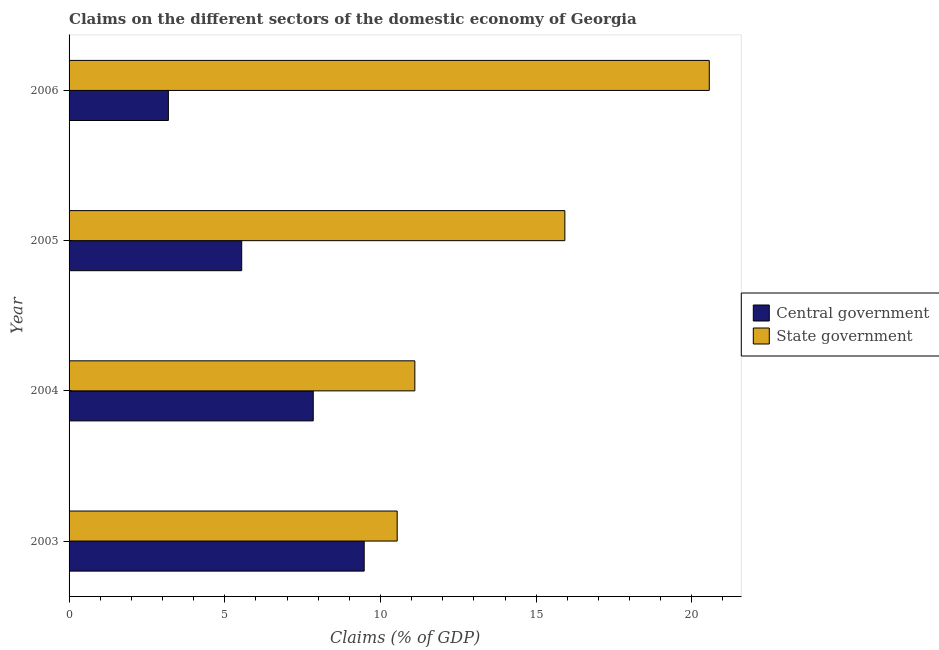Are the number of bars per tick equal to the number of legend labels?
Offer a very short reply. Yes. Are the number of bars on each tick of the Y-axis equal?
Provide a succinct answer. Yes. How many bars are there on the 1st tick from the top?
Your answer should be compact. 2. How many bars are there on the 2nd tick from the bottom?
Provide a succinct answer. 2. What is the label of the 3rd group of bars from the top?
Ensure brevity in your answer.  2004. In how many cases, is the number of bars for a given year not equal to the number of legend labels?
Offer a very short reply. 0. What is the claims on state government in 2006?
Make the answer very short. 20.56. Across all years, what is the maximum claims on central government?
Provide a succinct answer. 9.48. Across all years, what is the minimum claims on state government?
Keep it short and to the point. 10.54. In which year was the claims on central government maximum?
Provide a short and direct response. 2003. In which year was the claims on state government minimum?
Provide a succinct answer. 2003. What is the total claims on central government in the graph?
Your response must be concise. 26.05. What is the difference between the claims on state government in 2003 and that in 2004?
Provide a succinct answer. -0.57. What is the difference between the claims on central government in 2005 and the claims on state government in 2003?
Keep it short and to the point. -4.99. What is the average claims on state government per year?
Your answer should be compact. 14.53. In the year 2005, what is the difference between the claims on central government and claims on state government?
Make the answer very short. -10.38. In how many years, is the claims on state government greater than 18 %?
Provide a succinct answer. 1. What is the ratio of the claims on state government in 2003 to that in 2005?
Give a very brief answer. 0.66. What is the difference between the highest and the second highest claims on central government?
Your answer should be compact. 1.64. What is the difference between the highest and the lowest claims on state government?
Your answer should be compact. 10.02. In how many years, is the claims on state government greater than the average claims on state government taken over all years?
Ensure brevity in your answer.  2. What does the 1st bar from the top in 2005 represents?
Give a very brief answer. State government. What does the 2nd bar from the bottom in 2006 represents?
Offer a terse response. State government. How many years are there in the graph?
Make the answer very short. 4. What is the difference between two consecutive major ticks on the X-axis?
Keep it short and to the point. 5. Are the values on the major ticks of X-axis written in scientific E-notation?
Your answer should be compact. No. Where does the legend appear in the graph?
Provide a succinct answer. Center right. How are the legend labels stacked?
Ensure brevity in your answer.  Vertical. What is the title of the graph?
Give a very brief answer. Claims on the different sectors of the domestic economy of Georgia. Does "Foreign liabilities" appear as one of the legend labels in the graph?
Provide a succinct answer. No. What is the label or title of the X-axis?
Ensure brevity in your answer.  Claims (% of GDP). What is the label or title of the Y-axis?
Ensure brevity in your answer.  Year. What is the Claims (% of GDP) of Central government in 2003?
Your answer should be compact. 9.48. What is the Claims (% of GDP) of State government in 2003?
Ensure brevity in your answer.  10.54. What is the Claims (% of GDP) of Central government in 2004?
Give a very brief answer. 7.84. What is the Claims (% of GDP) of State government in 2004?
Keep it short and to the point. 11.1. What is the Claims (% of GDP) in Central government in 2005?
Make the answer very short. 5.54. What is the Claims (% of GDP) of State government in 2005?
Keep it short and to the point. 15.92. What is the Claims (% of GDP) of Central government in 2006?
Offer a terse response. 3.19. What is the Claims (% of GDP) in State government in 2006?
Offer a very short reply. 20.56. Across all years, what is the maximum Claims (% of GDP) in Central government?
Offer a very short reply. 9.48. Across all years, what is the maximum Claims (% of GDP) of State government?
Offer a terse response. 20.56. Across all years, what is the minimum Claims (% of GDP) of Central government?
Keep it short and to the point. 3.19. Across all years, what is the minimum Claims (% of GDP) in State government?
Offer a very short reply. 10.54. What is the total Claims (% of GDP) in Central government in the graph?
Offer a very short reply. 26.05. What is the total Claims (% of GDP) in State government in the graph?
Give a very brief answer. 58.12. What is the difference between the Claims (% of GDP) of Central government in 2003 and that in 2004?
Your response must be concise. 1.64. What is the difference between the Claims (% of GDP) of State government in 2003 and that in 2004?
Your answer should be very brief. -0.57. What is the difference between the Claims (% of GDP) of Central government in 2003 and that in 2005?
Ensure brevity in your answer.  3.93. What is the difference between the Claims (% of GDP) of State government in 2003 and that in 2005?
Keep it short and to the point. -5.38. What is the difference between the Claims (% of GDP) of Central government in 2003 and that in 2006?
Offer a terse response. 6.29. What is the difference between the Claims (% of GDP) of State government in 2003 and that in 2006?
Give a very brief answer. -10.02. What is the difference between the Claims (% of GDP) in Central government in 2004 and that in 2005?
Give a very brief answer. 2.3. What is the difference between the Claims (% of GDP) in State government in 2004 and that in 2005?
Offer a very short reply. -4.82. What is the difference between the Claims (% of GDP) of Central government in 2004 and that in 2006?
Your answer should be compact. 4.65. What is the difference between the Claims (% of GDP) of State government in 2004 and that in 2006?
Ensure brevity in your answer.  -9.46. What is the difference between the Claims (% of GDP) of Central government in 2005 and that in 2006?
Give a very brief answer. 2.35. What is the difference between the Claims (% of GDP) in State government in 2005 and that in 2006?
Make the answer very short. -4.64. What is the difference between the Claims (% of GDP) in Central government in 2003 and the Claims (% of GDP) in State government in 2004?
Provide a short and direct response. -1.63. What is the difference between the Claims (% of GDP) in Central government in 2003 and the Claims (% of GDP) in State government in 2005?
Your answer should be compact. -6.44. What is the difference between the Claims (% of GDP) in Central government in 2003 and the Claims (% of GDP) in State government in 2006?
Provide a short and direct response. -11.08. What is the difference between the Claims (% of GDP) in Central government in 2004 and the Claims (% of GDP) in State government in 2005?
Your response must be concise. -8.08. What is the difference between the Claims (% of GDP) in Central government in 2004 and the Claims (% of GDP) in State government in 2006?
Ensure brevity in your answer.  -12.72. What is the difference between the Claims (% of GDP) in Central government in 2005 and the Claims (% of GDP) in State government in 2006?
Provide a succinct answer. -15.02. What is the average Claims (% of GDP) in Central government per year?
Ensure brevity in your answer.  6.51. What is the average Claims (% of GDP) of State government per year?
Offer a very short reply. 14.53. In the year 2003, what is the difference between the Claims (% of GDP) in Central government and Claims (% of GDP) in State government?
Ensure brevity in your answer.  -1.06. In the year 2004, what is the difference between the Claims (% of GDP) in Central government and Claims (% of GDP) in State government?
Provide a short and direct response. -3.26. In the year 2005, what is the difference between the Claims (% of GDP) in Central government and Claims (% of GDP) in State government?
Keep it short and to the point. -10.38. In the year 2006, what is the difference between the Claims (% of GDP) in Central government and Claims (% of GDP) in State government?
Your answer should be very brief. -17.37. What is the ratio of the Claims (% of GDP) in Central government in 2003 to that in 2004?
Make the answer very short. 1.21. What is the ratio of the Claims (% of GDP) of State government in 2003 to that in 2004?
Make the answer very short. 0.95. What is the ratio of the Claims (% of GDP) in Central government in 2003 to that in 2005?
Your answer should be very brief. 1.71. What is the ratio of the Claims (% of GDP) of State government in 2003 to that in 2005?
Your response must be concise. 0.66. What is the ratio of the Claims (% of GDP) of Central government in 2003 to that in 2006?
Provide a succinct answer. 2.97. What is the ratio of the Claims (% of GDP) of State government in 2003 to that in 2006?
Offer a terse response. 0.51. What is the ratio of the Claims (% of GDP) of Central government in 2004 to that in 2005?
Provide a short and direct response. 1.41. What is the ratio of the Claims (% of GDP) in State government in 2004 to that in 2005?
Offer a very short reply. 0.7. What is the ratio of the Claims (% of GDP) of Central government in 2004 to that in 2006?
Keep it short and to the point. 2.46. What is the ratio of the Claims (% of GDP) of State government in 2004 to that in 2006?
Offer a very short reply. 0.54. What is the ratio of the Claims (% of GDP) of Central government in 2005 to that in 2006?
Offer a terse response. 1.74. What is the ratio of the Claims (% of GDP) of State government in 2005 to that in 2006?
Your answer should be compact. 0.77. What is the difference between the highest and the second highest Claims (% of GDP) in Central government?
Offer a very short reply. 1.64. What is the difference between the highest and the second highest Claims (% of GDP) of State government?
Give a very brief answer. 4.64. What is the difference between the highest and the lowest Claims (% of GDP) of Central government?
Give a very brief answer. 6.29. What is the difference between the highest and the lowest Claims (% of GDP) in State government?
Offer a terse response. 10.02. 